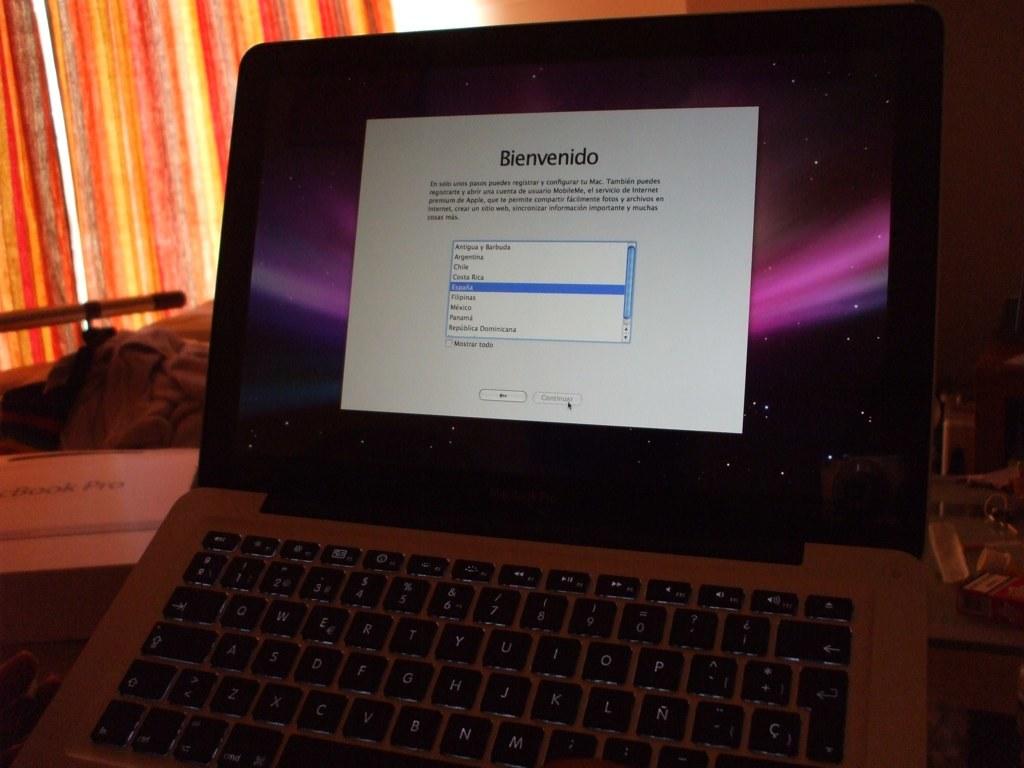What is the title of this page?
Make the answer very short. Bienvenido. What is the first letter on the word on the top of the screen?
Give a very brief answer. B. 